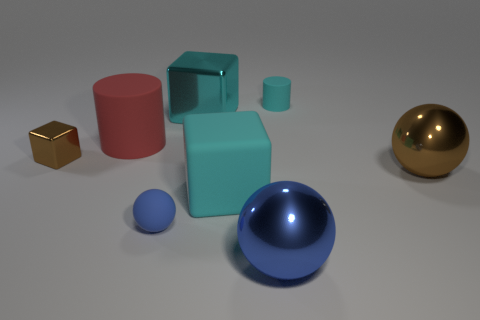How many objects are either rubber objects or big red cylinders?
Offer a terse response. 4. Are the large red cylinder and the brown object in front of the small brown metal cube made of the same material?
Your response must be concise. No. Is there any other thing that has the same color as the large metal block?
Give a very brief answer. Yes. How many objects are objects left of the red cylinder or big things right of the big cylinder?
Your response must be concise. 5. What is the shape of the metallic object that is in front of the small metallic thing and behind the tiny rubber sphere?
Provide a succinct answer. Sphere. How many small blue rubber things are behind the cyan matte thing in front of the small cyan cylinder?
Your answer should be compact. 0. Is there any other thing that has the same material as the big red cylinder?
Provide a succinct answer. Yes. How many objects are large cubes to the left of the matte block or big red cylinders?
Give a very brief answer. 2. There is a object behind the cyan metal block; how big is it?
Your answer should be very brief. Small. What is the small cylinder made of?
Ensure brevity in your answer.  Rubber. 